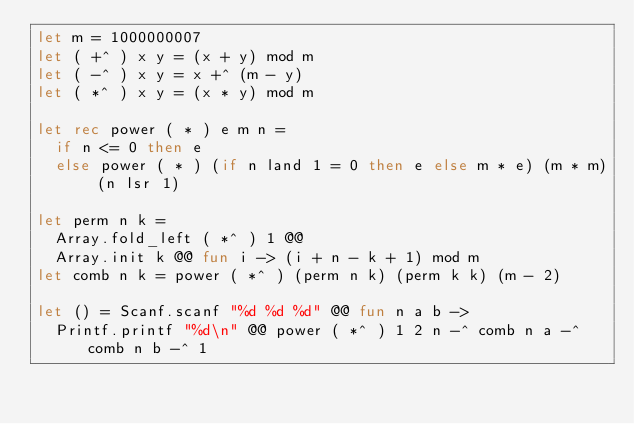<code> <loc_0><loc_0><loc_500><loc_500><_OCaml_>let m = 1000000007
let ( +^ ) x y = (x + y) mod m
let ( -^ ) x y = x +^ (m - y)
let ( *^ ) x y = (x * y) mod m

let rec power ( * ) e m n =
  if n <= 0 then e
  else power ( * ) (if n land 1 = 0 then e else m * e) (m * m) (n lsr 1)

let perm n k =
  Array.fold_left ( *^ ) 1 @@
  Array.init k @@ fun i -> (i + n - k + 1) mod m
let comb n k = power ( *^ ) (perm n k) (perm k k) (m - 2)

let () = Scanf.scanf "%d %d %d" @@ fun n a b ->
  Printf.printf "%d\n" @@ power ( *^ ) 1 2 n -^ comb n a -^ comb n b -^ 1</code> 